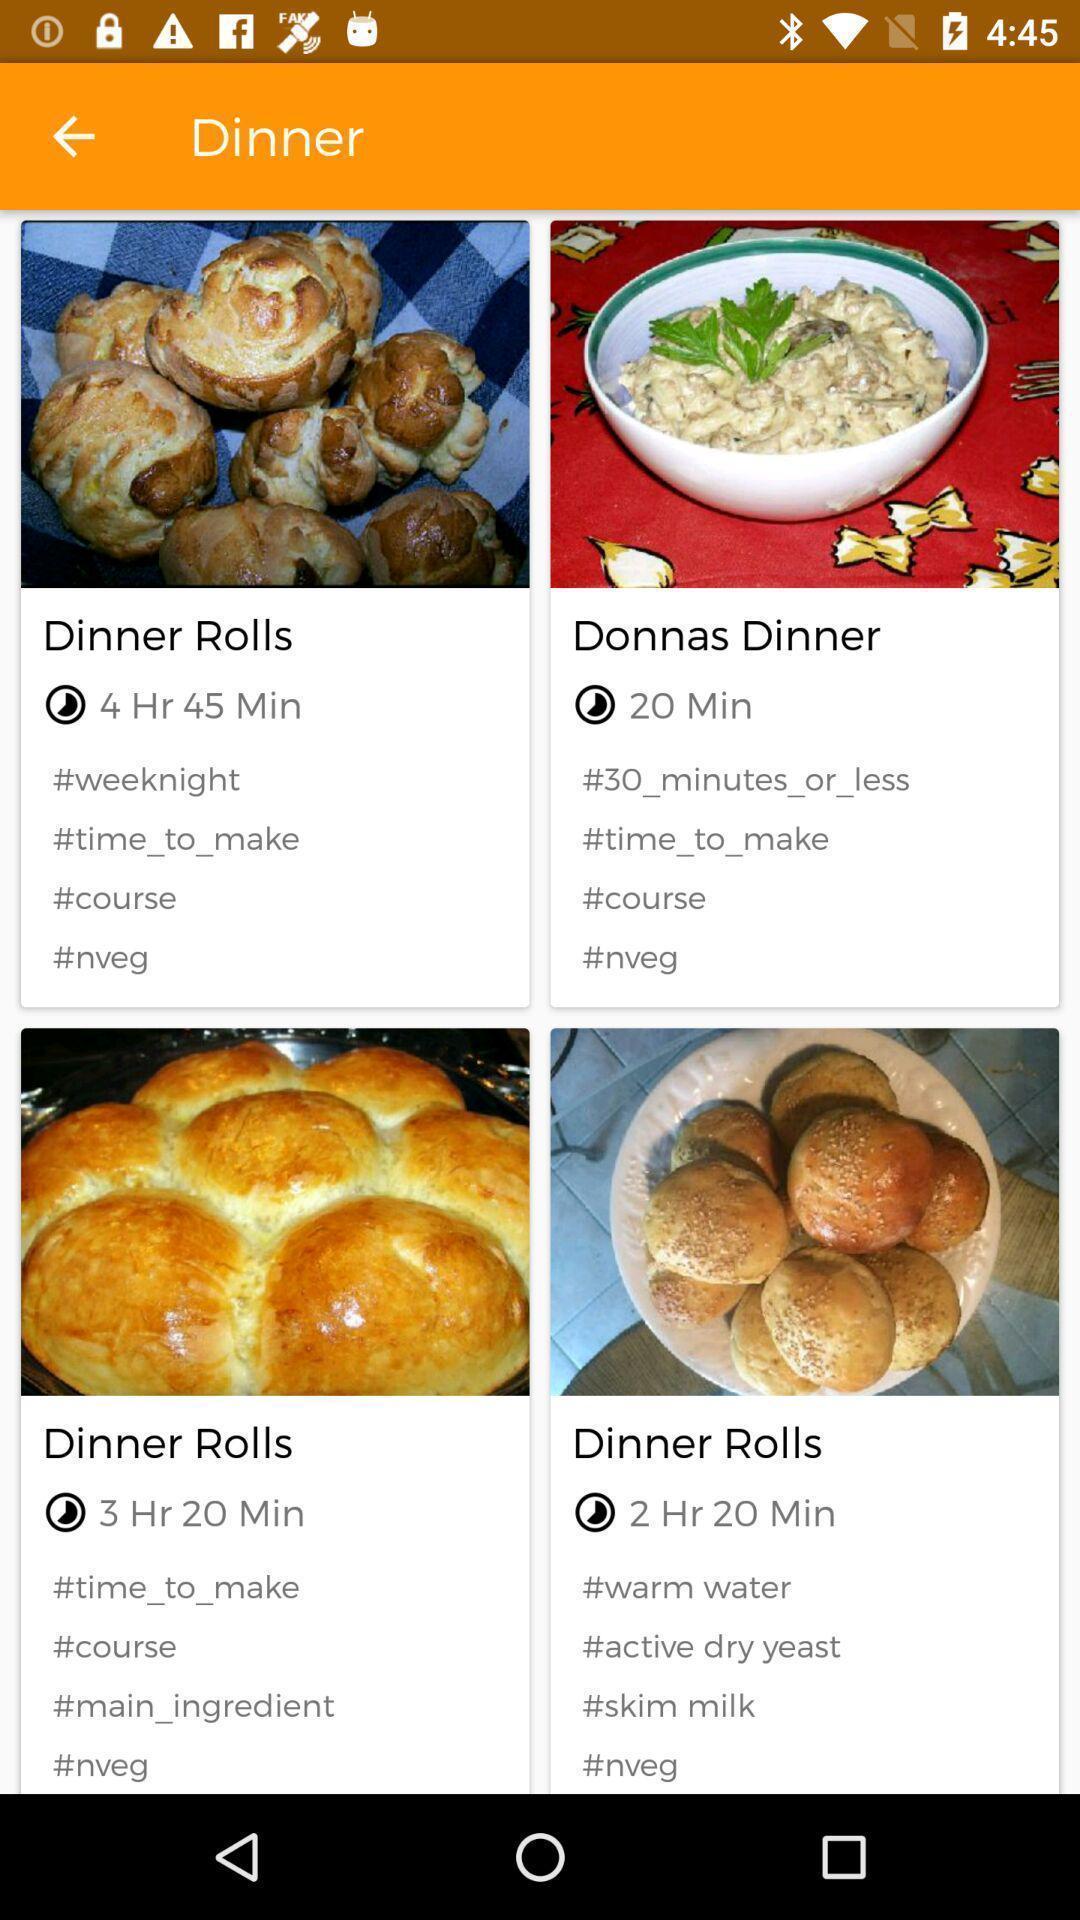Describe the key features of this screenshot. Window displaying menu for dinner. 